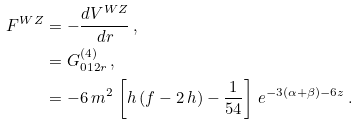Convert formula to latex. <formula><loc_0><loc_0><loc_500><loc_500>F ^ { W Z } & = - \frac { d V ^ { W Z } } { d r } \, , \\ & = G ^ { ( 4 ) } _ { 0 1 2 r } \, , \\ & = - 6 \, m ^ { 2 } \, \left [ h \, ( f - 2 \, h ) - \frac { 1 } { 5 4 } \right ] \, e ^ { - 3 ( \alpha + \beta ) - 6 z } \, .</formula> 